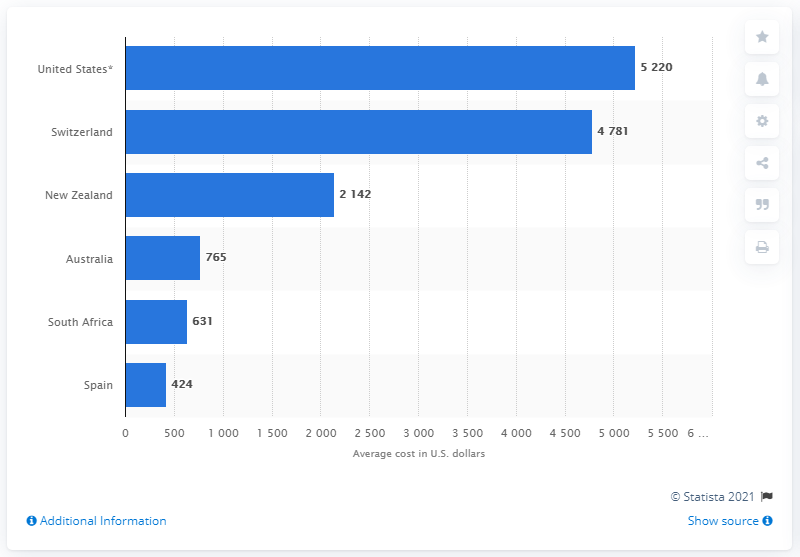Indicate a few pertinent items in this graphic. Switzerland has significantly lower hospital costs than the United States. The average cost per day to stay in a hospital in Spain was 424 U.S. dollars. 